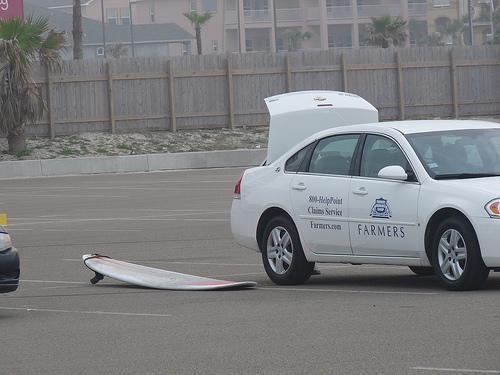How many cars are in the photo?
Give a very brief answer. 2. How many car trunks are open?
Give a very brief answer. 1. 